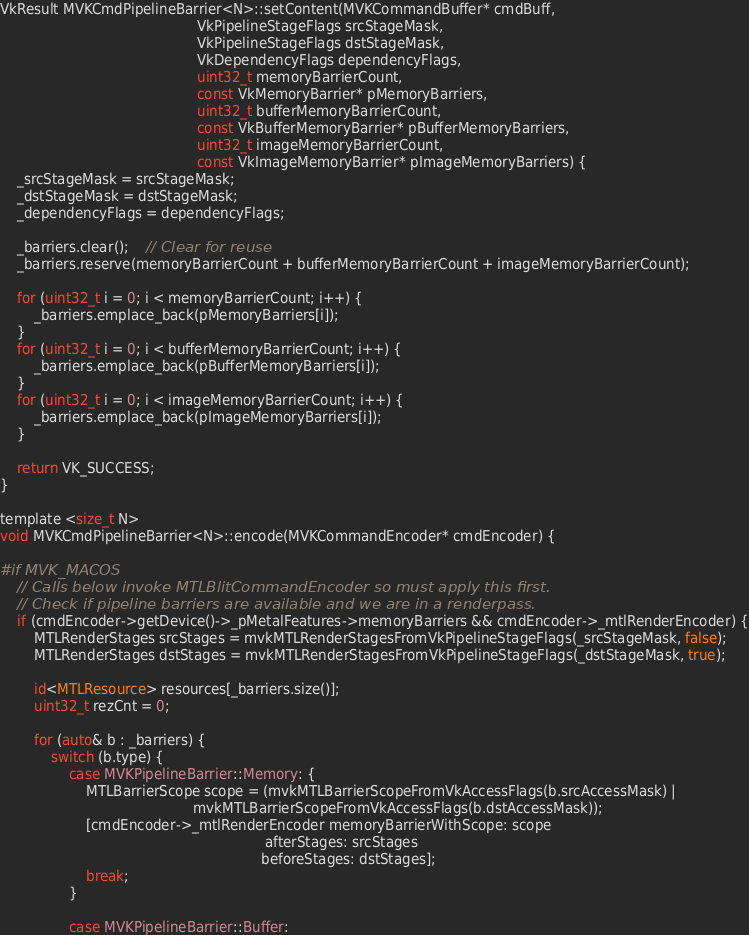Convert code to text. <code><loc_0><loc_0><loc_500><loc_500><_ObjectiveC_>VkResult MVKCmdPipelineBarrier<N>::setContent(MVKCommandBuffer* cmdBuff,
											  VkPipelineStageFlags srcStageMask,
											  VkPipelineStageFlags dstStageMask,
											  VkDependencyFlags dependencyFlags,
											  uint32_t memoryBarrierCount,
											  const VkMemoryBarrier* pMemoryBarriers,
											  uint32_t bufferMemoryBarrierCount,
											  const VkBufferMemoryBarrier* pBufferMemoryBarriers,
											  uint32_t imageMemoryBarrierCount,
											  const VkImageMemoryBarrier* pImageMemoryBarriers) {
	_srcStageMask = srcStageMask;
	_dstStageMask = dstStageMask;
	_dependencyFlags = dependencyFlags;

	_barriers.clear();	// Clear for reuse
	_barriers.reserve(memoryBarrierCount + bufferMemoryBarrierCount + imageMemoryBarrierCount);

	for (uint32_t i = 0; i < memoryBarrierCount; i++) {
		_barriers.emplace_back(pMemoryBarriers[i]);
	}
	for (uint32_t i = 0; i < bufferMemoryBarrierCount; i++) {
		_barriers.emplace_back(pBufferMemoryBarriers[i]);
	}
	for (uint32_t i = 0; i < imageMemoryBarrierCount; i++) {
		_barriers.emplace_back(pImageMemoryBarriers[i]);
	}

	return VK_SUCCESS;
}

template <size_t N>
void MVKCmdPipelineBarrier<N>::encode(MVKCommandEncoder* cmdEncoder) {

#if MVK_MACOS
	// Calls below invoke MTLBlitCommandEncoder so must apply this first.
	// Check if pipeline barriers are available and we are in a renderpass.
	if (cmdEncoder->getDevice()->_pMetalFeatures->memoryBarriers && cmdEncoder->_mtlRenderEncoder) {
		MTLRenderStages srcStages = mvkMTLRenderStagesFromVkPipelineStageFlags(_srcStageMask, false);
		MTLRenderStages dstStages = mvkMTLRenderStagesFromVkPipelineStageFlags(_dstStageMask, true);

		id<MTLResource> resources[_barriers.size()];
		uint32_t rezCnt = 0;

		for (auto& b : _barriers) {
			switch (b.type) {
				case MVKPipelineBarrier::Memory: {
					MTLBarrierScope scope = (mvkMTLBarrierScopeFromVkAccessFlags(b.srcAccessMask) |
											 mvkMTLBarrierScopeFromVkAccessFlags(b.dstAccessMask));
					[cmdEncoder->_mtlRenderEncoder memoryBarrierWithScope: scope
															  afterStages: srcStages
															 beforeStages: dstStages];
					break;
				}

				case MVKPipelineBarrier::Buffer:</code> 